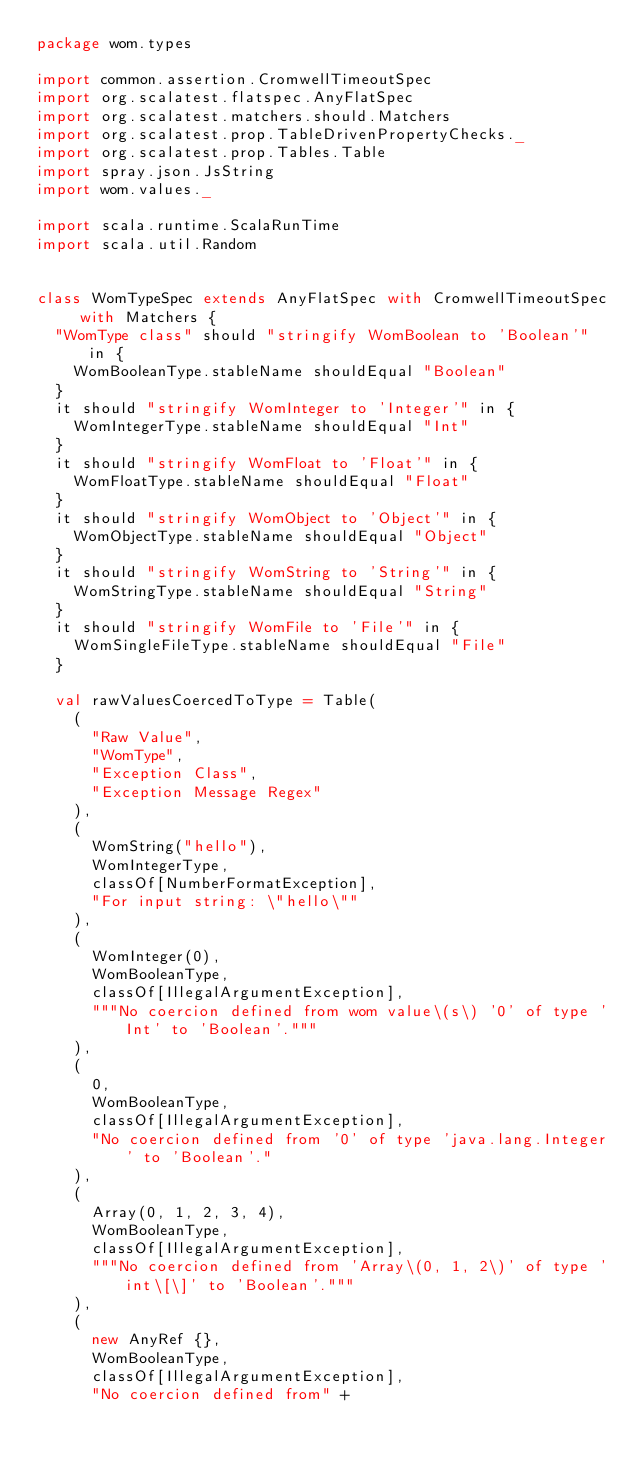Convert code to text. <code><loc_0><loc_0><loc_500><loc_500><_Scala_>package wom.types

import common.assertion.CromwellTimeoutSpec
import org.scalatest.flatspec.AnyFlatSpec
import org.scalatest.matchers.should.Matchers
import org.scalatest.prop.TableDrivenPropertyChecks._
import org.scalatest.prop.Tables.Table
import spray.json.JsString
import wom.values._

import scala.runtime.ScalaRunTime
import scala.util.Random


class WomTypeSpec extends AnyFlatSpec with CromwellTimeoutSpec with Matchers {
  "WomType class" should "stringify WomBoolean to 'Boolean'" in {
    WomBooleanType.stableName shouldEqual "Boolean"
  }
  it should "stringify WomInteger to 'Integer'" in {
    WomIntegerType.stableName shouldEqual "Int"
  }
  it should "stringify WomFloat to 'Float'" in {
    WomFloatType.stableName shouldEqual "Float"
  }
  it should "stringify WomObject to 'Object'" in {
    WomObjectType.stableName shouldEqual "Object"
  }
  it should "stringify WomString to 'String'" in {
    WomStringType.stableName shouldEqual "String"
  }
  it should "stringify WomFile to 'File'" in {
    WomSingleFileType.stableName shouldEqual "File"
  }

  val rawValuesCoercedToType = Table(
    (
      "Raw Value",
      "WomType",
      "Exception Class",
      "Exception Message Regex"
    ),
    (
      WomString("hello"),
      WomIntegerType,
      classOf[NumberFormatException],
      "For input string: \"hello\""
    ),
    (
      WomInteger(0),
      WomBooleanType,
      classOf[IllegalArgumentException],
      """No coercion defined from wom value\(s\) '0' of type 'Int' to 'Boolean'."""
    ),
    (
      0,
      WomBooleanType,
      classOf[IllegalArgumentException],
      "No coercion defined from '0' of type 'java.lang.Integer' to 'Boolean'."
    ),
    (
      Array(0, 1, 2, 3, 4),
      WomBooleanType,
      classOf[IllegalArgumentException],
      """No coercion defined from 'Array\(0, 1, 2\)' of type 'int\[\]' to 'Boolean'."""
    ),
    (
      new AnyRef {},
      WomBooleanType,
      classOf[IllegalArgumentException],
      "No coercion defined from" +</code> 